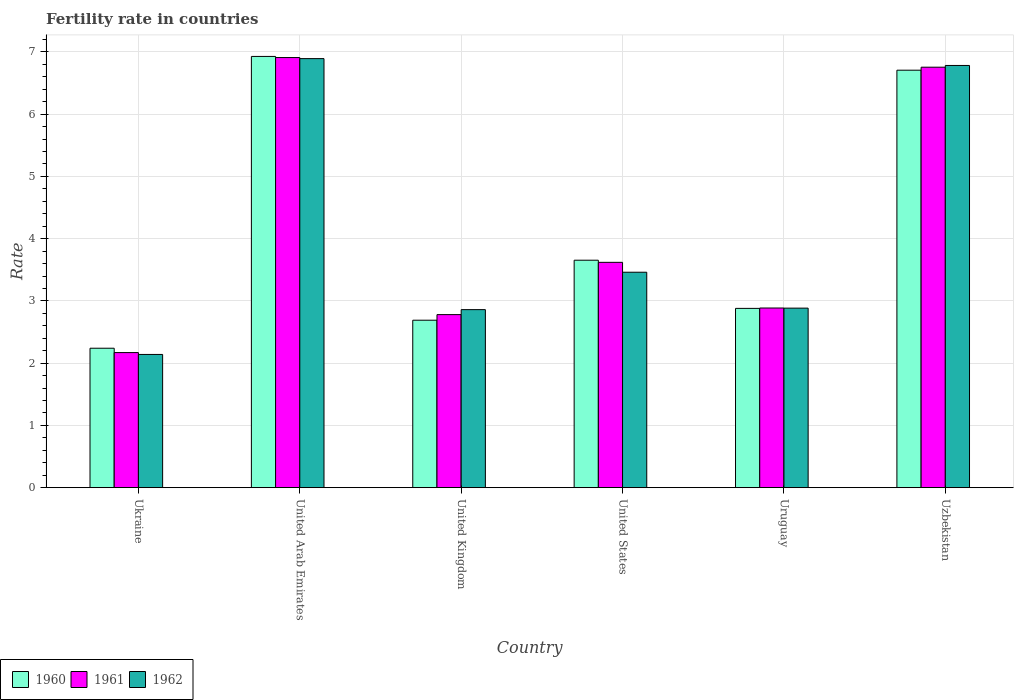How many groups of bars are there?
Ensure brevity in your answer.  6. Are the number of bars on each tick of the X-axis equal?
Your answer should be compact. Yes. How many bars are there on the 5th tick from the left?
Make the answer very short. 3. What is the label of the 6th group of bars from the left?
Make the answer very short. Uzbekistan. What is the fertility rate in 1961 in Ukraine?
Give a very brief answer. 2.17. Across all countries, what is the maximum fertility rate in 1960?
Your answer should be very brief. 6.93. Across all countries, what is the minimum fertility rate in 1961?
Provide a succinct answer. 2.17. In which country was the fertility rate in 1960 maximum?
Provide a short and direct response. United Arab Emirates. In which country was the fertility rate in 1962 minimum?
Provide a short and direct response. Ukraine. What is the total fertility rate in 1961 in the graph?
Offer a terse response. 25.12. What is the difference between the fertility rate in 1962 in United Arab Emirates and that in United Kingdom?
Your answer should be compact. 4.03. What is the difference between the fertility rate in 1960 in Uruguay and the fertility rate in 1962 in Ukraine?
Provide a short and direct response. 0.74. What is the average fertility rate in 1961 per country?
Give a very brief answer. 4.19. What is the difference between the fertility rate of/in 1962 and fertility rate of/in 1960 in United Arab Emirates?
Offer a terse response. -0.04. What is the ratio of the fertility rate in 1960 in United Arab Emirates to that in United States?
Provide a short and direct response. 1.9. Is the fertility rate in 1961 in United Kingdom less than that in Uruguay?
Provide a succinct answer. Yes. What is the difference between the highest and the second highest fertility rate in 1960?
Give a very brief answer. -3.27. What is the difference between the highest and the lowest fertility rate in 1960?
Offer a very short reply. 4.69. Is the sum of the fertility rate in 1960 in United Kingdom and Uruguay greater than the maximum fertility rate in 1962 across all countries?
Provide a succinct answer. No. What does the 1st bar from the left in Ukraine represents?
Your answer should be very brief. 1960. What does the 3rd bar from the right in United Kingdom represents?
Your response must be concise. 1960. How many bars are there?
Provide a succinct answer. 18. How many countries are there in the graph?
Offer a very short reply. 6. What is the difference between two consecutive major ticks on the Y-axis?
Make the answer very short. 1. Are the values on the major ticks of Y-axis written in scientific E-notation?
Keep it short and to the point. No. Does the graph contain grids?
Provide a short and direct response. Yes. Where does the legend appear in the graph?
Keep it short and to the point. Bottom left. What is the title of the graph?
Offer a very short reply. Fertility rate in countries. Does "1961" appear as one of the legend labels in the graph?
Offer a terse response. Yes. What is the label or title of the Y-axis?
Ensure brevity in your answer.  Rate. What is the Rate in 1960 in Ukraine?
Make the answer very short. 2.24. What is the Rate in 1961 in Ukraine?
Offer a very short reply. 2.17. What is the Rate in 1962 in Ukraine?
Your answer should be very brief. 2.14. What is the Rate in 1960 in United Arab Emirates?
Your response must be concise. 6.93. What is the Rate in 1961 in United Arab Emirates?
Ensure brevity in your answer.  6.91. What is the Rate in 1962 in United Arab Emirates?
Provide a succinct answer. 6.89. What is the Rate of 1960 in United Kingdom?
Your response must be concise. 2.69. What is the Rate of 1961 in United Kingdom?
Give a very brief answer. 2.78. What is the Rate of 1962 in United Kingdom?
Ensure brevity in your answer.  2.86. What is the Rate in 1960 in United States?
Give a very brief answer. 3.65. What is the Rate in 1961 in United States?
Offer a terse response. 3.62. What is the Rate in 1962 in United States?
Give a very brief answer. 3.46. What is the Rate in 1960 in Uruguay?
Make the answer very short. 2.88. What is the Rate of 1961 in Uruguay?
Offer a terse response. 2.89. What is the Rate of 1962 in Uruguay?
Your answer should be very brief. 2.88. What is the Rate of 1960 in Uzbekistan?
Offer a very short reply. 6.71. What is the Rate in 1961 in Uzbekistan?
Give a very brief answer. 6.75. What is the Rate in 1962 in Uzbekistan?
Ensure brevity in your answer.  6.78. Across all countries, what is the maximum Rate of 1960?
Your answer should be very brief. 6.93. Across all countries, what is the maximum Rate of 1961?
Provide a short and direct response. 6.91. Across all countries, what is the maximum Rate of 1962?
Make the answer very short. 6.89. Across all countries, what is the minimum Rate of 1960?
Your answer should be compact. 2.24. Across all countries, what is the minimum Rate of 1961?
Offer a terse response. 2.17. Across all countries, what is the minimum Rate of 1962?
Provide a short and direct response. 2.14. What is the total Rate in 1960 in the graph?
Offer a terse response. 25.1. What is the total Rate in 1961 in the graph?
Keep it short and to the point. 25.12. What is the total Rate in 1962 in the graph?
Offer a very short reply. 25.02. What is the difference between the Rate in 1960 in Ukraine and that in United Arab Emirates?
Provide a short and direct response. -4.69. What is the difference between the Rate of 1961 in Ukraine and that in United Arab Emirates?
Your response must be concise. -4.74. What is the difference between the Rate of 1962 in Ukraine and that in United Arab Emirates?
Your response must be concise. -4.75. What is the difference between the Rate of 1960 in Ukraine and that in United Kingdom?
Your answer should be compact. -0.45. What is the difference between the Rate in 1961 in Ukraine and that in United Kingdom?
Make the answer very short. -0.61. What is the difference between the Rate in 1962 in Ukraine and that in United Kingdom?
Offer a very short reply. -0.72. What is the difference between the Rate of 1960 in Ukraine and that in United States?
Provide a succinct answer. -1.41. What is the difference between the Rate in 1961 in Ukraine and that in United States?
Give a very brief answer. -1.45. What is the difference between the Rate of 1962 in Ukraine and that in United States?
Provide a short and direct response. -1.32. What is the difference between the Rate in 1960 in Ukraine and that in Uruguay?
Give a very brief answer. -0.64. What is the difference between the Rate of 1961 in Ukraine and that in Uruguay?
Give a very brief answer. -0.72. What is the difference between the Rate in 1962 in Ukraine and that in Uruguay?
Offer a terse response. -0.74. What is the difference between the Rate in 1960 in Ukraine and that in Uzbekistan?
Give a very brief answer. -4.47. What is the difference between the Rate in 1961 in Ukraine and that in Uzbekistan?
Keep it short and to the point. -4.58. What is the difference between the Rate in 1962 in Ukraine and that in Uzbekistan?
Offer a very short reply. -4.64. What is the difference between the Rate of 1960 in United Arab Emirates and that in United Kingdom?
Provide a succinct answer. 4.24. What is the difference between the Rate in 1961 in United Arab Emirates and that in United Kingdom?
Offer a terse response. 4.13. What is the difference between the Rate in 1962 in United Arab Emirates and that in United Kingdom?
Provide a succinct answer. 4.03. What is the difference between the Rate of 1960 in United Arab Emirates and that in United States?
Offer a very short reply. 3.27. What is the difference between the Rate in 1961 in United Arab Emirates and that in United States?
Your answer should be compact. 3.29. What is the difference between the Rate of 1962 in United Arab Emirates and that in United States?
Ensure brevity in your answer.  3.43. What is the difference between the Rate of 1960 in United Arab Emirates and that in Uruguay?
Make the answer very short. 4.05. What is the difference between the Rate in 1961 in United Arab Emirates and that in Uruguay?
Your answer should be very brief. 4.02. What is the difference between the Rate of 1962 in United Arab Emirates and that in Uruguay?
Provide a short and direct response. 4.01. What is the difference between the Rate in 1960 in United Arab Emirates and that in Uzbekistan?
Provide a short and direct response. 0.22. What is the difference between the Rate of 1961 in United Arab Emirates and that in Uzbekistan?
Offer a terse response. 0.15. What is the difference between the Rate in 1962 in United Arab Emirates and that in Uzbekistan?
Keep it short and to the point. 0.11. What is the difference between the Rate in 1960 in United Kingdom and that in United States?
Offer a terse response. -0.96. What is the difference between the Rate in 1961 in United Kingdom and that in United States?
Keep it short and to the point. -0.84. What is the difference between the Rate in 1962 in United Kingdom and that in United States?
Provide a short and direct response. -0.6. What is the difference between the Rate in 1960 in United Kingdom and that in Uruguay?
Offer a terse response. -0.19. What is the difference between the Rate in 1961 in United Kingdom and that in Uruguay?
Offer a terse response. -0.11. What is the difference between the Rate of 1962 in United Kingdom and that in Uruguay?
Your answer should be compact. -0.02. What is the difference between the Rate of 1960 in United Kingdom and that in Uzbekistan?
Offer a very short reply. -4.02. What is the difference between the Rate in 1961 in United Kingdom and that in Uzbekistan?
Your answer should be compact. -3.98. What is the difference between the Rate of 1962 in United Kingdom and that in Uzbekistan?
Ensure brevity in your answer.  -3.92. What is the difference between the Rate in 1960 in United States and that in Uruguay?
Keep it short and to the point. 0.77. What is the difference between the Rate in 1961 in United States and that in Uruguay?
Give a very brief answer. 0.73. What is the difference between the Rate of 1962 in United States and that in Uruguay?
Offer a very short reply. 0.58. What is the difference between the Rate in 1960 in United States and that in Uzbekistan?
Provide a short and direct response. -3.05. What is the difference between the Rate in 1961 in United States and that in Uzbekistan?
Your response must be concise. -3.13. What is the difference between the Rate in 1962 in United States and that in Uzbekistan?
Your answer should be compact. -3.32. What is the difference between the Rate of 1960 in Uruguay and that in Uzbekistan?
Make the answer very short. -3.83. What is the difference between the Rate in 1961 in Uruguay and that in Uzbekistan?
Your response must be concise. -3.87. What is the difference between the Rate of 1962 in Uruguay and that in Uzbekistan?
Give a very brief answer. -3.9. What is the difference between the Rate of 1960 in Ukraine and the Rate of 1961 in United Arab Emirates?
Provide a succinct answer. -4.67. What is the difference between the Rate in 1960 in Ukraine and the Rate in 1962 in United Arab Emirates?
Your answer should be compact. -4.65. What is the difference between the Rate of 1961 in Ukraine and the Rate of 1962 in United Arab Emirates?
Offer a very short reply. -4.72. What is the difference between the Rate of 1960 in Ukraine and the Rate of 1961 in United Kingdom?
Give a very brief answer. -0.54. What is the difference between the Rate of 1960 in Ukraine and the Rate of 1962 in United Kingdom?
Your answer should be compact. -0.62. What is the difference between the Rate of 1961 in Ukraine and the Rate of 1962 in United Kingdom?
Ensure brevity in your answer.  -0.69. What is the difference between the Rate of 1960 in Ukraine and the Rate of 1961 in United States?
Give a very brief answer. -1.38. What is the difference between the Rate of 1960 in Ukraine and the Rate of 1962 in United States?
Make the answer very short. -1.22. What is the difference between the Rate in 1961 in Ukraine and the Rate in 1962 in United States?
Your answer should be very brief. -1.29. What is the difference between the Rate of 1960 in Ukraine and the Rate of 1961 in Uruguay?
Your answer should be very brief. -0.65. What is the difference between the Rate of 1960 in Ukraine and the Rate of 1962 in Uruguay?
Provide a succinct answer. -0.64. What is the difference between the Rate in 1961 in Ukraine and the Rate in 1962 in Uruguay?
Provide a succinct answer. -0.71. What is the difference between the Rate in 1960 in Ukraine and the Rate in 1961 in Uzbekistan?
Make the answer very short. -4.51. What is the difference between the Rate in 1960 in Ukraine and the Rate in 1962 in Uzbekistan?
Your answer should be very brief. -4.54. What is the difference between the Rate of 1961 in Ukraine and the Rate of 1962 in Uzbekistan?
Offer a terse response. -4.61. What is the difference between the Rate in 1960 in United Arab Emirates and the Rate in 1961 in United Kingdom?
Your answer should be compact. 4.15. What is the difference between the Rate in 1960 in United Arab Emirates and the Rate in 1962 in United Kingdom?
Offer a terse response. 4.07. What is the difference between the Rate of 1961 in United Arab Emirates and the Rate of 1962 in United Kingdom?
Provide a short and direct response. 4.05. What is the difference between the Rate of 1960 in United Arab Emirates and the Rate of 1961 in United States?
Keep it short and to the point. 3.31. What is the difference between the Rate of 1960 in United Arab Emirates and the Rate of 1962 in United States?
Offer a terse response. 3.47. What is the difference between the Rate in 1961 in United Arab Emirates and the Rate in 1962 in United States?
Your response must be concise. 3.45. What is the difference between the Rate in 1960 in United Arab Emirates and the Rate in 1961 in Uruguay?
Your answer should be compact. 4.04. What is the difference between the Rate of 1960 in United Arab Emirates and the Rate of 1962 in Uruguay?
Offer a very short reply. 4.04. What is the difference between the Rate in 1961 in United Arab Emirates and the Rate in 1962 in Uruguay?
Provide a succinct answer. 4.03. What is the difference between the Rate in 1960 in United Arab Emirates and the Rate in 1961 in Uzbekistan?
Offer a very short reply. 0.17. What is the difference between the Rate of 1960 in United Arab Emirates and the Rate of 1962 in Uzbekistan?
Provide a succinct answer. 0.14. What is the difference between the Rate of 1961 in United Arab Emirates and the Rate of 1962 in Uzbekistan?
Provide a short and direct response. 0.13. What is the difference between the Rate in 1960 in United Kingdom and the Rate in 1961 in United States?
Provide a short and direct response. -0.93. What is the difference between the Rate of 1960 in United Kingdom and the Rate of 1962 in United States?
Ensure brevity in your answer.  -0.77. What is the difference between the Rate in 1961 in United Kingdom and the Rate in 1962 in United States?
Your response must be concise. -0.68. What is the difference between the Rate in 1960 in United Kingdom and the Rate in 1961 in Uruguay?
Keep it short and to the point. -0.2. What is the difference between the Rate of 1960 in United Kingdom and the Rate of 1962 in Uruguay?
Your answer should be very brief. -0.19. What is the difference between the Rate of 1961 in United Kingdom and the Rate of 1962 in Uruguay?
Offer a very short reply. -0.1. What is the difference between the Rate in 1960 in United Kingdom and the Rate in 1961 in Uzbekistan?
Offer a terse response. -4.07. What is the difference between the Rate in 1960 in United Kingdom and the Rate in 1962 in Uzbekistan?
Your answer should be compact. -4.09. What is the difference between the Rate in 1961 in United Kingdom and the Rate in 1962 in Uzbekistan?
Your answer should be compact. -4. What is the difference between the Rate in 1960 in United States and the Rate in 1961 in Uruguay?
Offer a terse response. 0.77. What is the difference between the Rate in 1960 in United States and the Rate in 1962 in Uruguay?
Ensure brevity in your answer.  0.77. What is the difference between the Rate of 1961 in United States and the Rate of 1962 in Uruguay?
Your answer should be compact. 0.74. What is the difference between the Rate of 1960 in United States and the Rate of 1961 in Uzbekistan?
Make the answer very short. -3.1. What is the difference between the Rate in 1960 in United States and the Rate in 1962 in Uzbekistan?
Give a very brief answer. -3.13. What is the difference between the Rate of 1961 in United States and the Rate of 1962 in Uzbekistan?
Your response must be concise. -3.16. What is the difference between the Rate in 1960 in Uruguay and the Rate in 1961 in Uzbekistan?
Your answer should be compact. -3.88. What is the difference between the Rate in 1960 in Uruguay and the Rate in 1962 in Uzbekistan?
Offer a terse response. -3.9. What is the difference between the Rate in 1961 in Uruguay and the Rate in 1962 in Uzbekistan?
Your response must be concise. -3.9. What is the average Rate in 1960 per country?
Your answer should be compact. 4.18. What is the average Rate of 1961 per country?
Provide a succinct answer. 4.19. What is the average Rate in 1962 per country?
Ensure brevity in your answer.  4.17. What is the difference between the Rate of 1960 and Rate of 1961 in Ukraine?
Provide a short and direct response. 0.07. What is the difference between the Rate in 1960 and Rate in 1961 in United Arab Emirates?
Give a very brief answer. 0.02. What is the difference between the Rate in 1960 and Rate in 1962 in United Arab Emirates?
Make the answer very short. 0.04. What is the difference between the Rate in 1961 and Rate in 1962 in United Arab Emirates?
Ensure brevity in your answer.  0.02. What is the difference between the Rate in 1960 and Rate in 1961 in United Kingdom?
Offer a very short reply. -0.09. What is the difference between the Rate of 1960 and Rate of 1962 in United Kingdom?
Make the answer very short. -0.17. What is the difference between the Rate of 1961 and Rate of 1962 in United Kingdom?
Give a very brief answer. -0.08. What is the difference between the Rate of 1960 and Rate of 1961 in United States?
Offer a very short reply. 0.03. What is the difference between the Rate of 1960 and Rate of 1962 in United States?
Provide a short and direct response. 0.19. What is the difference between the Rate of 1961 and Rate of 1962 in United States?
Offer a very short reply. 0.16. What is the difference between the Rate of 1960 and Rate of 1961 in Uruguay?
Provide a succinct answer. -0.01. What is the difference between the Rate in 1960 and Rate in 1962 in Uruguay?
Provide a succinct answer. -0. What is the difference between the Rate of 1961 and Rate of 1962 in Uruguay?
Provide a succinct answer. 0. What is the difference between the Rate of 1960 and Rate of 1961 in Uzbekistan?
Provide a short and direct response. -0.05. What is the difference between the Rate of 1960 and Rate of 1962 in Uzbekistan?
Offer a terse response. -0.08. What is the difference between the Rate of 1961 and Rate of 1962 in Uzbekistan?
Offer a very short reply. -0.03. What is the ratio of the Rate in 1960 in Ukraine to that in United Arab Emirates?
Make the answer very short. 0.32. What is the ratio of the Rate in 1961 in Ukraine to that in United Arab Emirates?
Keep it short and to the point. 0.31. What is the ratio of the Rate of 1962 in Ukraine to that in United Arab Emirates?
Keep it short and to the point. 0.31. What is the ratio of the Rate in 1960 in Ukraine to that in United Kingdom?
Your answer should be very brief. 0.83. What is the ratio of the Rate of 1961 in Ukraine to that in United Kingdom?
Offer a very short reply. 0.78. What is the ratio of the Rate of 1962 in Ukraine to that in United Kingdom?
Provide a short and direct response. 0.75. What is the ratio of the Rate in 1960 in Ukraine to that in United States?
Keep it short and to the point. 0.61. What is the ratio of the Rate in 1961 in Ukraine to that in United States?
Ensure brevity in your answer.  0.6. What is the ratio of the Rate of 1962 in Ukraine to that in United States?
Offer a terse response. 0.62. What is the ratio of the Rate of 1960 in Ukraine to that in Uruguay?
Your response must be concise. 0.78. What is the ratio of the Rate of 1961 in Ukraine to that in Uruguay?
Your answer should be compact. 0.75. What is the ratio of the Rate of 1962 in Ukraine to that in Uruguay?
Keep it short and to the point. 0.74. What is the ratio of the Rate of 1960 in Ukraine to that in Uzbekistan?
Provide a succinct answer. 0.33. What is the ratio of the Rate of 1961 in Ukraine to that in Uzbekistan?
Offer a very short reply. 0.32. What is the ratio of the Rate of 1962 in Ukraine to that in Uzbekistan?
Your response must be concise. 0.32. What is the ratio of the Rate of 1960 in United Arab Emirates to that in United Kingdom?
Provide a short and direct response. 2.58. What is the ratio of the Rate in 1961 in United Arab Emirates to that in United Kingdom?
Your answer should be compact. 2.49. What is the ratio of the Rate of 1962 in United Arab Emirates to that in United Kingdom?
Your answer should be compact. 2.41. What is the ratio of the Rate of 1960 in United Arab Emirates to that in United States?
Ensure brevity in your answer.  1.9. What is the ratio of the Rate of 1961 in United Arab Emirates to that in United States?
Ensure brevity in your answer.  1.91. What is the ratio of the Rate in 1962 in United Arab Emirates to that in United States?
Your answer should be very brief. 1.99. What is the ratio of the Rate of 1960 in United Arab Emirates to that in Uruguay?
Make the answer very short. 2.41. What is the ratio of the Rate in 1961 in United Arab Emirates to that in Uruguay?
Make the answer very short. 2.39. What is the ratio of the Rate of 1962 in United Arab Emirates to that in Uruguay?
Give a very brief answer. 2.39. What is the ratio of the Rate of 1960 in United Arab Emirates to that in Uzbekistan?
Your answer should be compact. 1.03. What is the ratio of the Rate of 1961 in United Arab Emirates to that in Uzbekistan?
Provide a succinct answer. 1.02. What is the ratio of the Rate of 1962 in United Arab Emirates to that in Uzbekistan?
Offer a very short reply. 1.02. What is the ratio of the Rate in 1960 in United Kingdom to that in United States?
Make the answer very short. 0.74. What is the ratio of the Rate in 1961 in United Kingdom to that in United States?
Provide a short and direct response. 0.77. What is the ratio of the Rate of 1962 in United Kingdom to that in United States?
Provide a short and direct response. 0.83. What is the ratio of the Rate of 1960 in United Kingdom to that in Uruguay?
Give a very brief answer. 0.93. What is the ratio of the Rate in 1961 in United Kingdom to that in Uruguay?
Make the answer very short. 0.96. What is the ratio of the Rate in 1962 in United Kingdom to that in Uruguay?
Your answer should be compact. 0.99. What is the ratio of the Rate of 1960 in United Kingdom to that in Uzbekistan?
Offer a very short reply. 0.4. What is the ratio of the Rate in 1961 in United Kingdom to that in Uzbekistan?
Offer a very short reply. 0.41. What is the ratio of the Rate in 1962 in United Kingdom to that in Uzbekistan?
Give a very brief answer. 0.42. What is the ratio of the Rate of 1960 in United States to that in Uruguay?
Give a very brief answer. 1.27. What is the ratio of the Rate of 1961 in United States to that in Uruguay?
Your answer should be very brief. 1.25. What is the ratio of the Rate in 1962 in United States to that in Uruguay?
Your response must be concise. 1.2. What is the ratio of the Rate of 1960 in United States to that in Uzbekistan?
Offer a terse response. 0.54. What is the ratio of the Rate in 1961 in United States to that in Uzbekistan?
Keep it short and to the point. 0.54. What is the ratio of the Rate of 1962 in United States to that in Uzbekistan?
Ensure brevity in your answer.  0.51. What is the ratio of the Rate in 1960 in Uruguay to that in Uzbekistan?
Give a very brief answer. 0.43. What is the ratio of the Rate of 1961 in Uruguay to that in Uzbekistan?
Make the answer very short. 0.43. What is the ratio of the Rate of 1962 in Uruguay to that in Uzbekistan?
Give a very brief answer. 0.43. What is the difference between the highest and the second highest Rate of 1960?
Provide a short and direct response. 0.22. What is the difference between the highest and the second highest Rate of 1961?
Provide a succinct answer. 0.15. What is the difference between the highest and the second highest Rate of 1962?
Give a very brief answer. 0.11. What is the difference between the highest and the lowest Rate of 1960?
Give a very brief answer. 4.69. What is the difference between the highest and the lowest Rate in 1961?
Provide a short and direct response. 4.74. What is the difference between the highest and the lowest Rate in 1962?
Offer a very short reply. 4.75. 